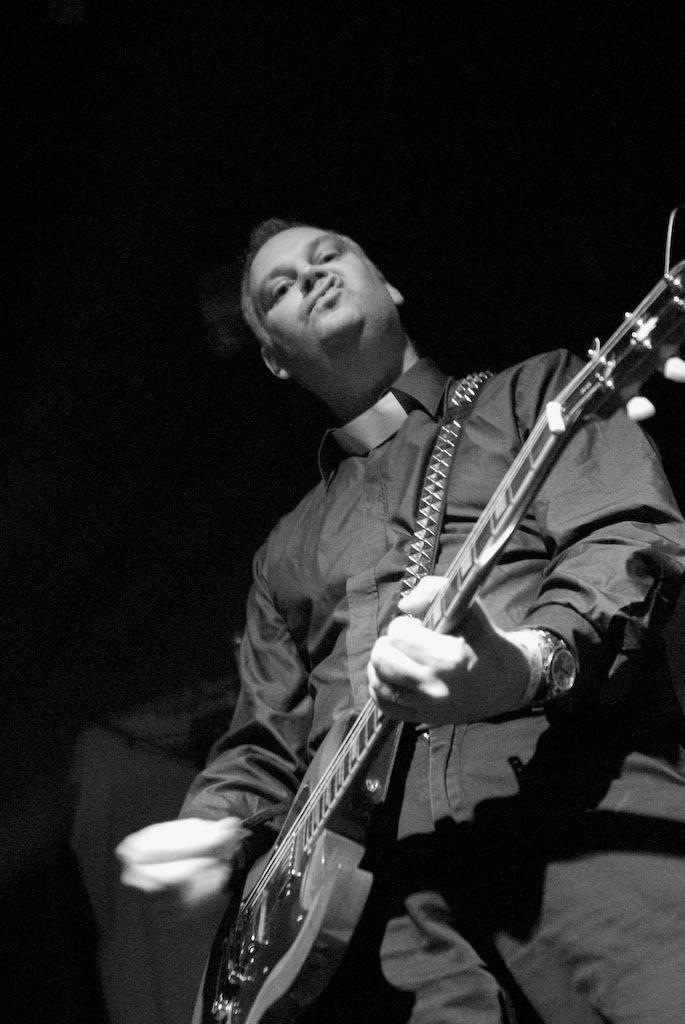How would you summarize this image in a sentence or two? a person is standing, playing a guitar. he is wearing a watch. this is a black and white image. 